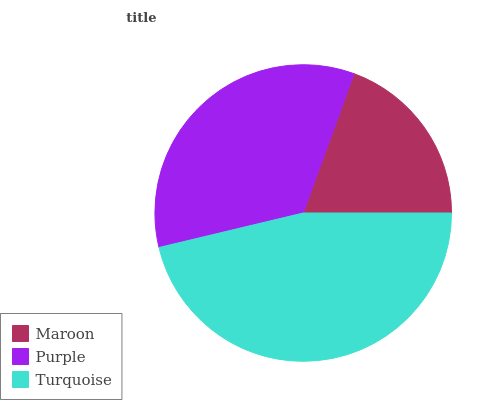Is Maroon the minimum?
Answer yes or no. Yes. Is Turquoise the maximum?
Answer yes or no. Yes. Is Purple the minimum?
Answer yes or no. No. Is Purple the maximum?
Answer yes or no. No. Is Purple greater than Maroon?
Answer yes or no. Yes. Is Maroon less than Purple?
Answer yes or no. Yes. Is Maroon greater than Purple?
Answer yes or no. No. Is Purple less than Maroon?
Answer yes or no. No. Is Purple the high median?
Answer yes or no. Yes. Is Purple the low median?
Answer yes or no. Yes. Is Turquoise the high median?
Answer yes or no. No. Is Turquoise the low median?
Answer yes or no. No. 